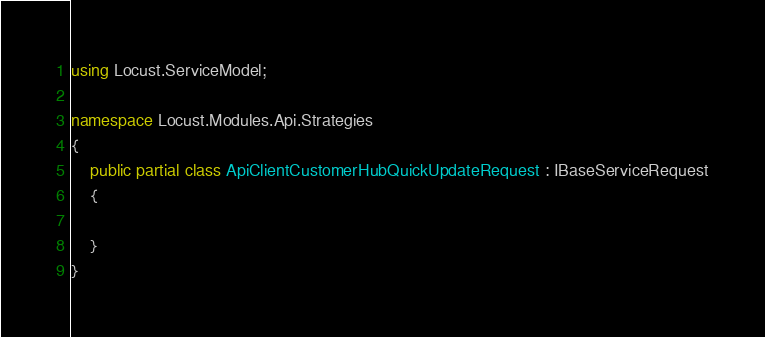<code> <loc_0><loc_0><loc_500><loc_500><_C#_>using Locust.ServiceModel;

namespace Locust.Modules.Api.Strategies
{
	public partial class ApiClientCustomerHubQuickUpdateRequest : IBaseServiceRequest
    {
		
    }
}</code> 